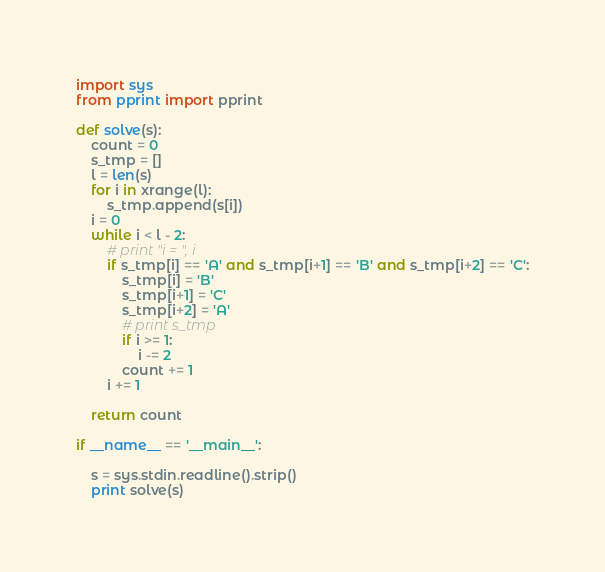Convert code to text. <code><loc_0><loc_0><loc_500><loc_500><_Python_>import sys
from pprint import pprint

def solve(s):
    count = 0
    s_tmp = []
    l = len(s)
    for i in xrange(l):
        s_tmp.append(s[i])
    i = 0
    while i < l - 2:
        # print "i = ", i
        if s_tmp[i] == 'A' and s_tmp[i+1] == 'B' and s_tmp[i+2] == 'C':
            s_tmp[i] = 'B'
            s_tmp[i+1] = 'C'
            s_tmp[i+2] = 'A'
            # print s_tmp
            if i >= 1:
                i -= 2
            count += 1
        i += 1

    return count

if __name__ == '__main__':

    s = sys.stdin.readline().strip()
    print solve(s)</code> 